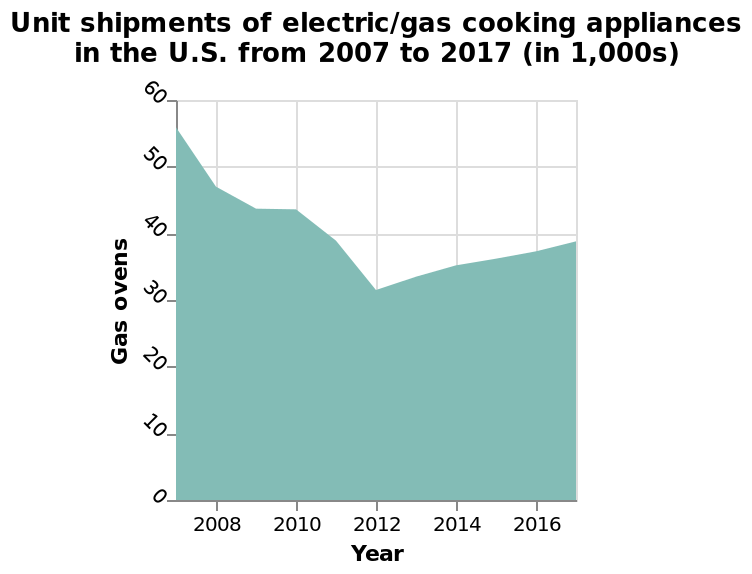<image>
Offer a thorough analysis of the image. U.S. consumers started to move away from gas driven appliances, presumably based on the cost of electricity falling overall int he US in the period in question. We start to see a resurgence in gas appliances in 2012, as gas became cheaper. Why did the cost of electricity fall overall in the US? The cost of electricity fell overall in the US, prompting consumers to move away from gas driven appliances, although the specific reason is not mentioned. Could you provide the unit shipment values in the form of thousands for gas ovens in the U.S. from 2007 to 2017?  Sorry, the exact unit shipment values are not mentioned in the given description. 